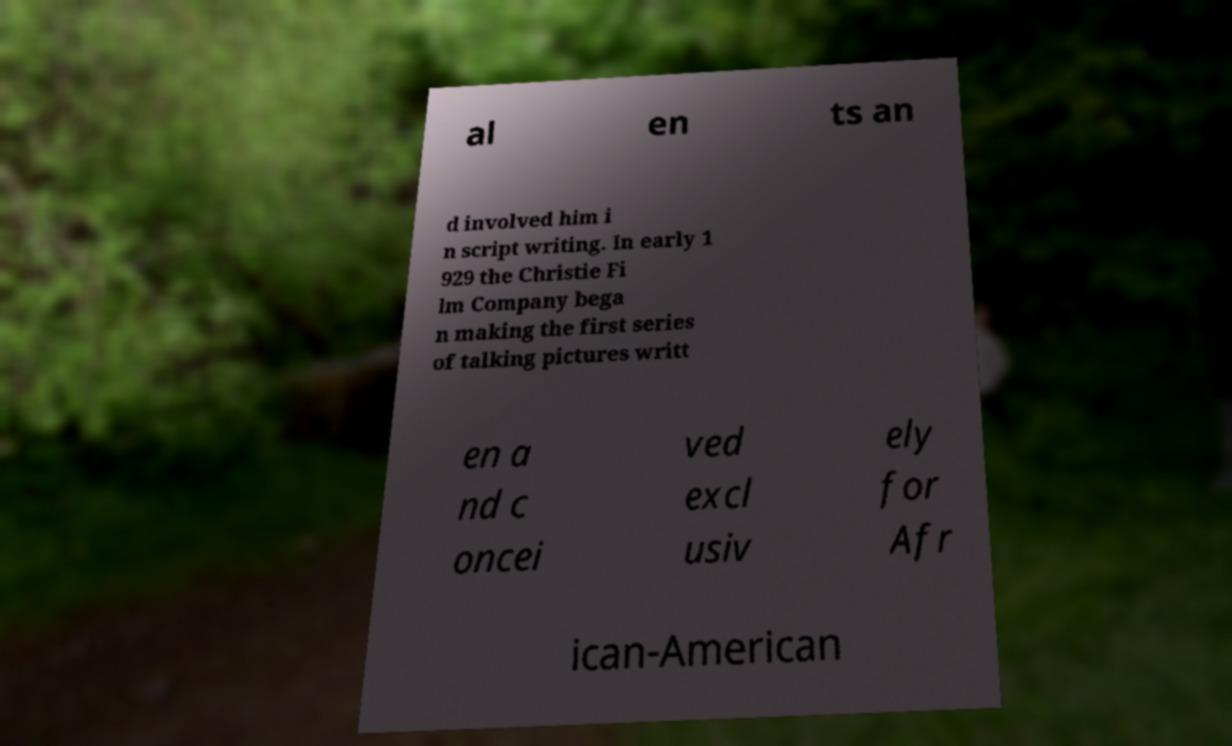For documentation purposes, I need the text within this image transcribed. Could you provide that? al en ts an d involved him i n script writing. In early 1 929 the Christie Fi lm Company bega n making the first series of talking pictures writt en a nd c oncei ved excl usiv ely for Afr ican-American 